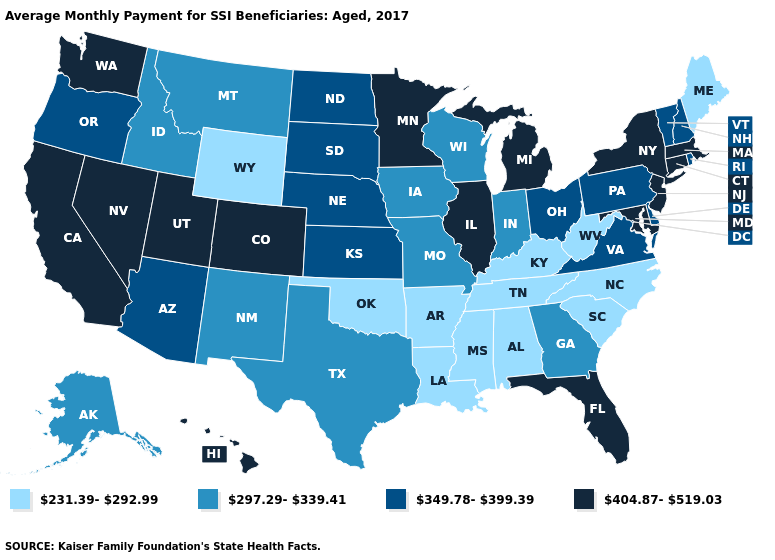Does Pennsylvania have the same value as Arizona?
Quick response, please. Yes. What is the value of Maine?
Be succinct. 231.39-292.99. What is the lowest value in states that border Colorado?
Give a very brief answer. 231.39-292.99. Name the states that have a value in the range 349.78-399.39?
Concise answer only. Arizona, Delaware, Kansas, Nebraska, New Hampshire, North Dakota, Ohio, Oregon, Pennsylvania, Rhode Island, South Dakota, Vermont, Virginia. Does Wisconsin have the highest value in the MidWest?
Short answer required. No. Does Rhode Island have a higher value than South Carolina?
Keep it brief. Yes. What is the value of Georgia?
Short answer required. 297.29-339.41. What is the value of Hawaii?
Short answer required. 404.87-519.03. Name the states that have a value in the range 231.39-292.99?
Keep it brief. Alabama, Arkansas, Kentucky, Louisiana, Maine, Mississippi, North Carolina, Oklahoma, South Carolina, Tennessee, West Virginia, Wyoming. Does Texas have a higher value than New Jersey?
Concise answer only. No. Among the states that border Missouri , which have the highest value?
Short answer required. Illinois. Among the states that border Massachusetts , does New York have the highest value?
Short answer required. Yes. Does Alaska have the same value as Missouri?
Write a very short answer. Yes. Name the states that have a value in the range 349.78-399.39?
Keep it brief. Arizona, Delaware, Kansas, Nebraska, New Hampshire, North Dakota, Ohio, Oregon, Pennsylvania, Rhode Island, South Dakota, Vermont, Virginia. Name the states that have a value in the range 349.78-399.39?
Answer briefly. Arizona, Delaware, Kansas, Nebraska, New Hampshire, North Dakota, Ohio, Oregon, Pennsylvania, Rhode Island, South Dakota, Vermont, Virginia. 